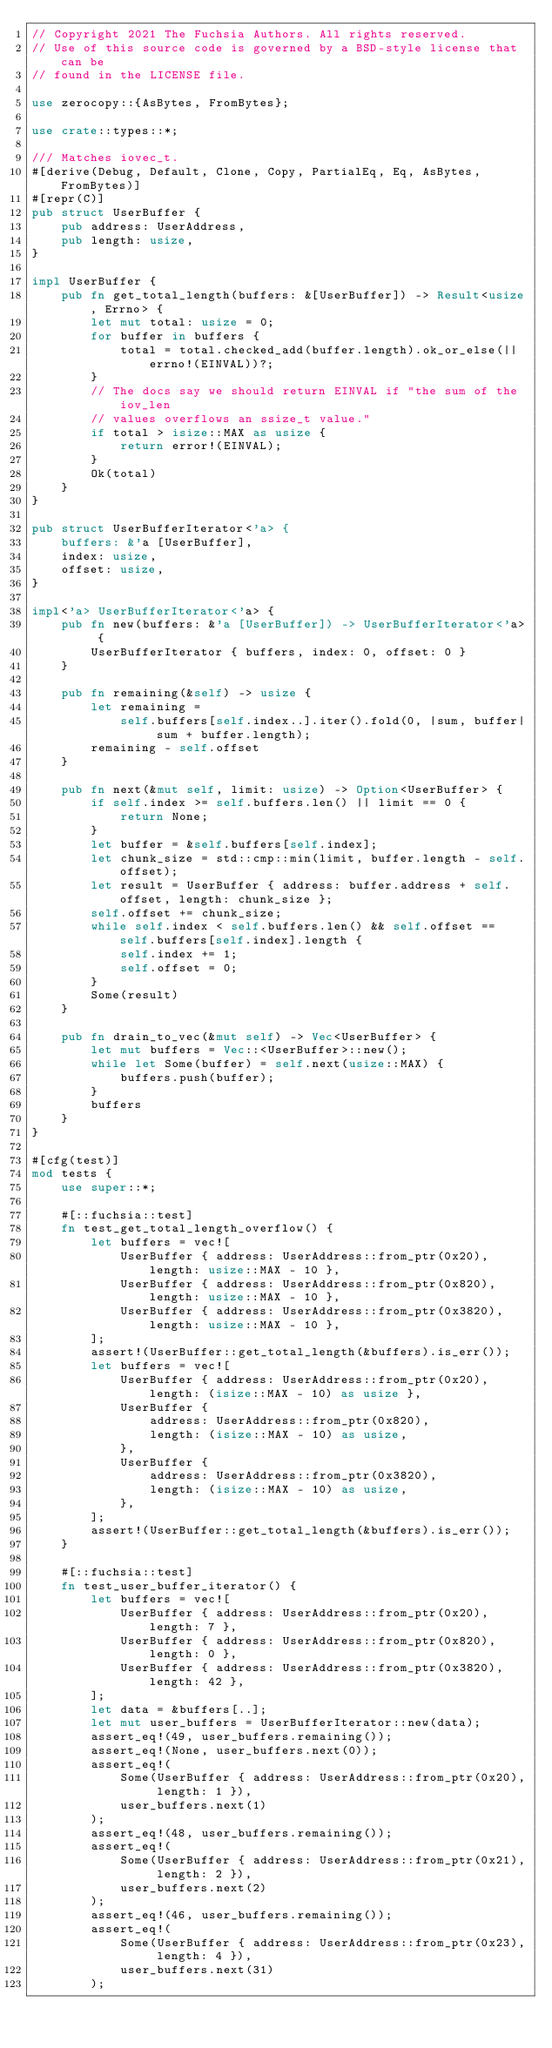Convert code to text. <code><loc_0><loc_0><loc_500><loc_500><_Rust_>// Copyright 2021 The Fuchsia Authors. All rights reserved.
// Use of this source code is governed by a BSD-style license that can be
// found in the LICENSE file.

use zerocopy::{AsBytes, FromBytes};

use crate::types::*;

/// Matches iovec_t.
#[derive(Debug, Default, Clone, Copy, PartialEq, Eq, AsBytes, FromBytes)]
#[repr(C)]
pub struct UserBuffer {
    pub address: UserAddress,
    pub length: usize,
}

impl UserBuffer {
    pub fn get_total_length(buffers: &[UserBuffer]) -> Result<usize, Errno> {
        let mut total: usize = 0;
        for buffer in buffers {
            total = total.checked_add(buffer.length).ok_or_else(|| errno!(EINVAL))?;
        }
        // The docs say we should return EINVAL if "the sum of the iov_len
        // values overflows an ssize_t value."
        if total > isize::MAX as usize {
            return error!(EINVAL);
        }
        Ok(total)
    }
}

pub struct UserBufferIterator<'a> {
    buffers: &'a [UserBuffer],
    index: usize,
    offset: usize,
}

impl<'a> UserBufferIterator<'a> {
    pub fn new(buffers: &'a [UserBuffer]) -> UserBufferIterator<'a> {
        UserBufferIterator { buffers, index: 0, offset: 0 }
    }

    pub fn remaining(&self) -> usize {
        let remaining =
            self.buffers[self.index..].iter().fold(0, |sum, buffer| sum + buffer.length);
        remaining - self.offset
    }

    pub fn next(&mut self, limit: usize) -> Option<UserBuffer> {
        if self.index >= self.buffers.len() || limit == 0 {
            return None;
        }
        let buffer = &self.buffers[self.index];
        let chunk_size = std::cmp::min(limit, buffer.length - self.offset);
        let result = UserBuffer { address: buffer.address + self.offset, length: chunk_size };
        self.offset += chunk_size;
        while self.index < self.buffers.len() && self.offset == self.buffers[self.index].length {
            self.index += 1;
            self.offset = 0;
        }
        Some(result)
    }

    pub fn drain_to_vec(&mut self) -> Vec<UserBuffer> {
        let mut buffers = Vec::<UserBuffer>::new();
        while let Some(buffer) = self.next(usize::MAX) {
            buffers.push(buffer);
        }
        buffers
    }
}

#[cfg(test)]
mod tests {
    use super::*;

    #[::fuchsia::test]
    fn test_get_total_length_overflow() {
        let buffers = vec![
            UserBuffer { address: UserAddress::from_ptr(0x20), length: usize::MAX - 10 },
            UserBuffer { address: UserAddress::from_ptr(0x820), length: usize::MAX - 10 },
            UserBuffer { address: UserAddress::from_ptr(0x3820), length: usize::MAX - 10 },
        ];
        assert!(UserBuffer::get_total_length(&buffers).is_err());
        let buffers = vec![
            UserBuffer { address: UserAddress::from_ptr(0x20), length: (isize::MAX - 10) as usize },
            UserBuffer {
                address: UserAddress::from_ptr(0x820),
                length: (isize::MAX - 10) as usize,
            },
            UserBuffer {
                address: UserAddress::from_ptr(0x3820),
                length: (isize::MAX - 10) as usize,
            },
        ];
        assert!(UserBuffer::get_total_length(&buffers).is_err());
    }

    #[::fuchsia::test]
    fn test_user_buffer_iterator() {
        let buffers = vec![
            UserBuffer { address: UserAddress::from_ptr(0x20), length: 7 },
            UserBuffer { address: UserAddress::from_ptr(0x820), length: 0 },
            UserBuffer { address: UserAddress::from_ptr(0x3820), length: 42 },
        ];
        let data = &buffers[..];
        let mut user_buffers = UserBufferIterator::new(data);
        assert_eq!(49, user_buffers.remaining());
        assert_eq!(None, user_buffers.next(0));
        assert_eq!(
            Some(UserBuffer { address: UserAddress::from_ptr(0x20), length: 1 }),
            user_buffers.next(1)
        );
        assert_eq!(48, user_buffers.remaining());
        assert_eq!(
            Some(UserBuffer { address: UserAddress::from_ptr(0x21), length: 2 }),
            user_buffers.next(2)
        );
        assert_eq!(46, user_buffers.remaining());
        assert_eq!(
            Some(UserBuffer { address: UserAddress::from_ptr(0x23), length: 4 }),
            user_buffers.next(31)
        );</code> 